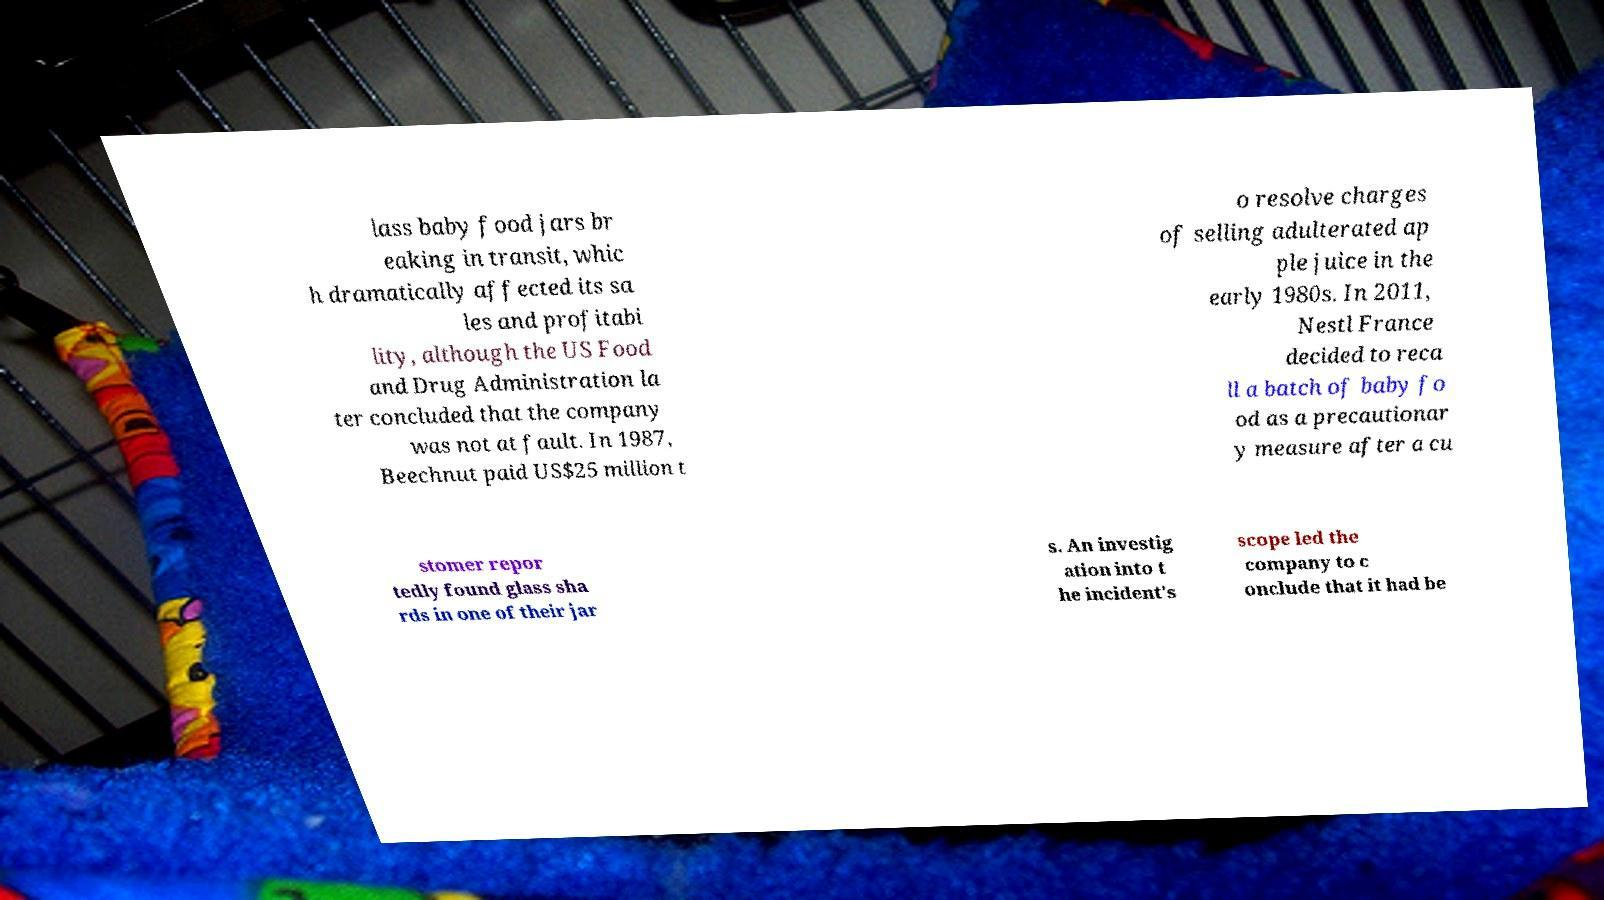Could you extract and type out the text from this image? lass baby food jars br eaking in transit, whic h dramatically affected its sa les and profitabi lity, although the US Food and Drug Administration la ter concluded that the company was not at fault. In 1987, Beechnut paid US$25 million t o resolve charges of selling adulterated ap ple juice in the early 1980s. In 2011, Nestl France decided to reca ll a batch of baby fo od as a precautionar y measure after a cu stomer repor tedly found glass sha rds in one of their jar s. An investig ation into t he incident's scope led the company to c onclude that it had be 